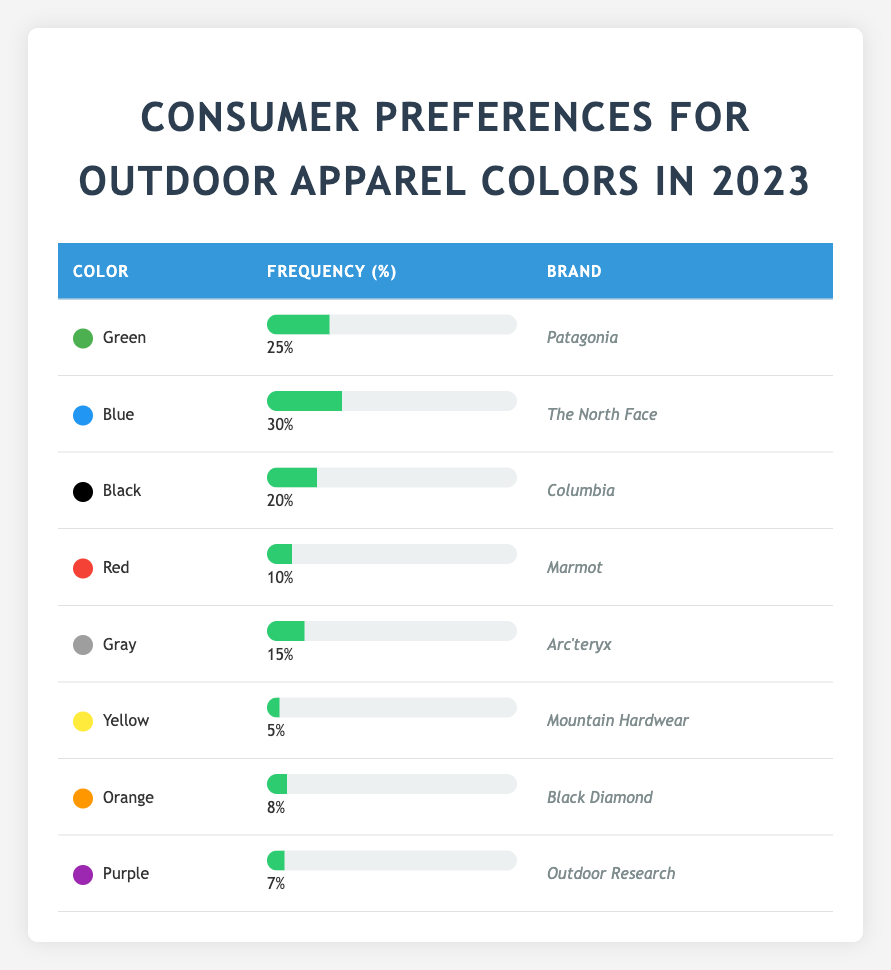What color has the highest frequency preference among consumers in 2023? By scanning the frequency column in the table, we can see that the color with the highest frequency is Blue with a frequency of 30.
Answer: Blue Which brand corresponds to the color Green? In the table, the color Green is listed next to the brand Patagonia.
Answer: Patagonia What is the total frequency of preferences for colors Black and Gray combined? The frequency for Black is 20 and for Gray is 15. Adding these together gives 20 + 15 = 35.
Answer: 35 Is the frequency for the color Yellow greater than the frequency for the color Orange? The frequency for Yellow is 5, while for Orange, it is 8. Since 5 is not greater than 8, the answer is no.
Answer: No What percentage of consumers prefer Red and Purple combined? The frequency for Red is 10 and for Purple is 7. Adding these gives 10 + 7 = 17. Therefore, the combined preference percentage is 17%.
Answer: 17 Which color is less preferred, Yellow or Gray? The frequency for Yellow is 5, and the frequency for Gray is 15. Since 5 is less than 15, Yellow is less preferred.
Answer: Yellow What is the average frequency of preference for all the colors listed in the table? We add up all the frequencies: 25 + 30 + 20 + 10 + 15 + 5 + 8 + 7 = 120. There are 8 colors, so the average is 120/8 = 15.
Answer: 15 Does the brand The North Face have a higher preference frequency than the brand Marmot? The frequency for The North Face is 30, while for Marmot, it is 10. Since 30 is greater than 10, the answer is yes.
Answer: Yes What is the difference in preference frequency between the color Blue and the color Black? The frequency for Blue is 30 and for Black, it is 20. The difference is 30 - 20 = 10.
Answer: 10 